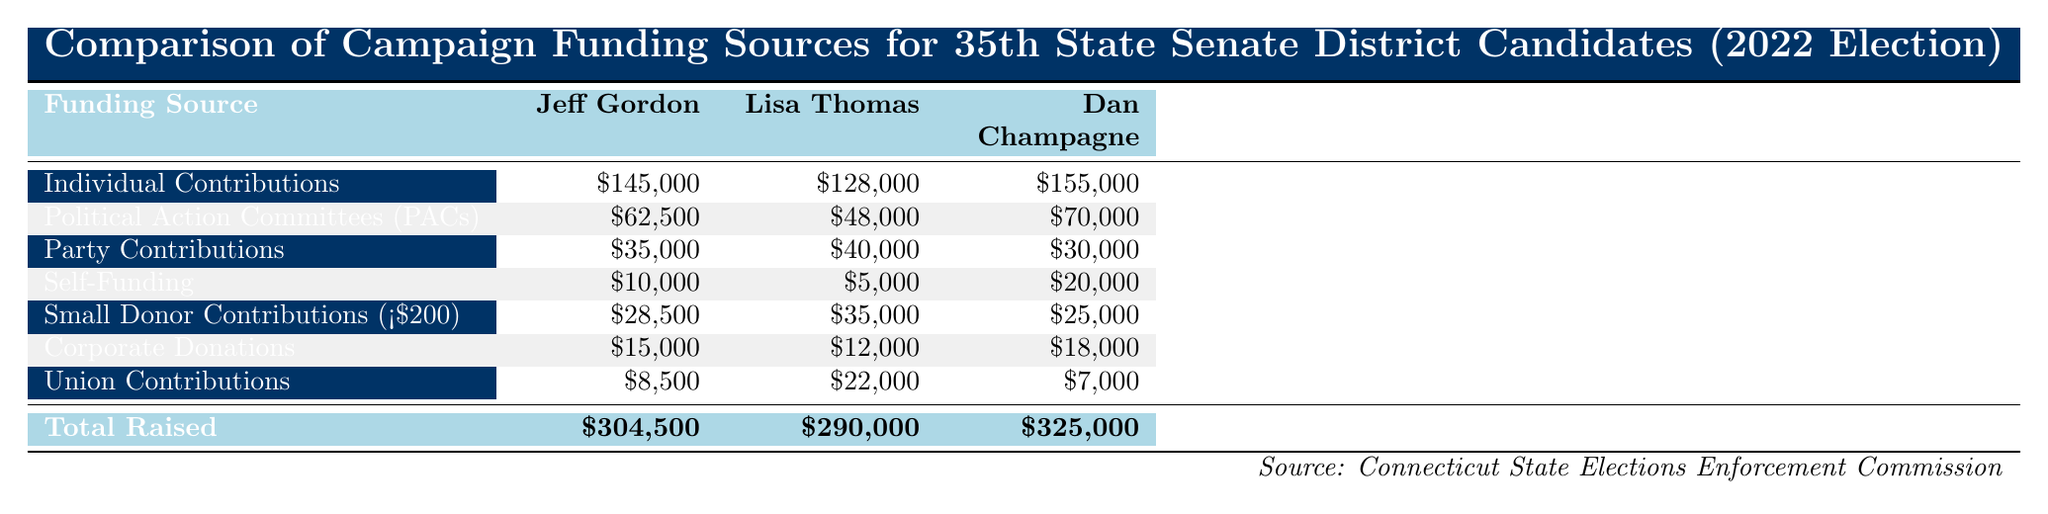What is the total amount raised by Dan Champagne? The table indicates that the total amount raised by Dan Champagne is shown in the last row under "Total Raised." It states that Dan Champagne raised a total of $325,000.
Answer: $325,000 Which candidate received the highest individual contributions? By comparing the values in the "Individual Contributions" row for each candidate, Jeff Gordon has $145,000, Lisa Thomas has $128,000, and Dan Champagne has $155,000. Dan Champagne has the highest amount at $155,000.
Answer: Dan Champagne What is the difference in total funds raised between Jeff Gordon and Lisa Thomas? The total funds raised for Jeff Gordon is $304,500, and for Lisa Thomas, it is $290,000. The difference can be calculated as $304,500 - $290,000 = $14,500.
Answer: $14,500 Did Lisa Thomas receive more Union Contributions than Dan Champagne? Looking at the "Union Contributions" row, Lisa Thomas received $22,000 while Dan Champagne received $7,000. Since $22,000 is greater than $7,000, the answer is yes.
Answer: Yes What was the average amount raised from Small Donor Contributions across all candidates? The Small Donor Contributions are $28,500 for Jeff Gordon, $35,000 for Lisa Thomas, and $25,000 for Dan Champagne. First, sum these values: $28,500 + $35,000 + $25,000 = $88,500. There are 3 candidates, so we divide by 3 to find the average, which is $88,500 / 3 = $29,500.
Answer: $29,500 Which candidate received the least amount in Self-Funding? For Self-Funding, Jeff Gordon received $10,000, Lisa Thomas received $5,000, and Dan Champagne received $20,000. The smallest amount is $5,000 from Lisa Thomas.
Answer: Lisa Thomas What was the total amount received from Corporate Donations by all candidates? The Corporate Donations are $15,000 for Jeff Gordon, $12,000 for Lisa Thomas, and $18,000 for Dan Champagne. Adding these together gives $15,000 + $12,000 + $18,000 = $45,000.
Answer: $45,000 Was the total amount raised by candidates predominantly from Individual Contributions? To determine this, we compare the total raised amounts with the total from Individual Contributions. The individual contributions are $145,000 (Gordon) + $128,000 (Thomas) + $155,000 (Champagne) = $428,000. The total raised by all candidates is $304,500 + $290,000 + $325,000 = $919,500. Since $428,000 is less than $919,500, the statement is false.
Answer: No How much more did Dan Champagne raise from Political Action Committees (PACs) compared to Lisa Thomas? Dan Champagne raised $70,000 from PACs, and Lisa Thomas raised $48,000. The difference is calculated as $70,000 - $48,000 = $22,000.
Answer: $22,000 